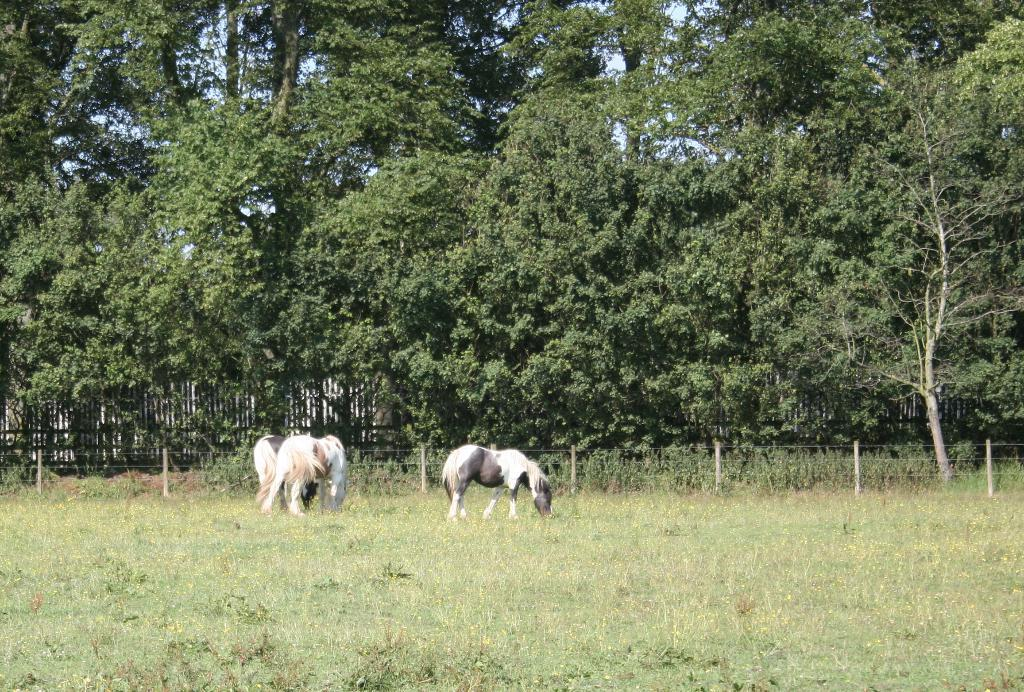How many horses are in the image? There are three horses in the image. What are the horses doing in the image? The horses are eating grass. What type of vegetation is on the ground in the image? There is grass on the ground. What can be seen in the background of the image? There is a fence and trees behind the fence in the background of the image. What type of umbrella is being used by the horses in the image? There is no umbrella present in the image; the horses are eating grass. How many legs does each horse have in the image? The horses in the image have four legs each, as horses typically do. 